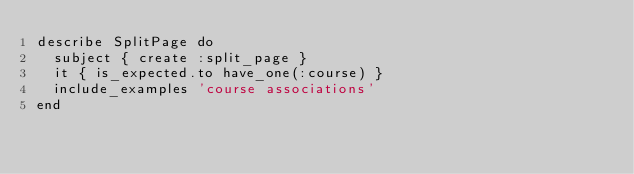Convert code to text. <code><loc_0><loc_0><loc_500><loc_500><_Ruby_>describe SplitPage do
  subject { create :split_page }
  it { is_expected.to have_one(:course) }
  include_examples 'course associations'
end
</code> 